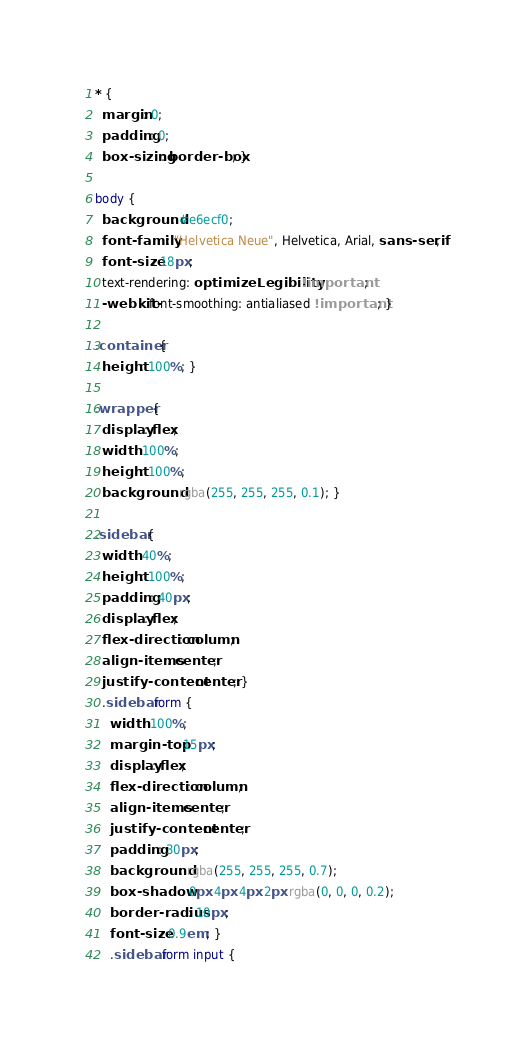Convert code to text. <code><loc_0><loc_0><loc_500><loc_500><_CSS_>* {
  margin: 0;
  padding: 0;
  box-sizing: border-box; }

body {
  background: #e6ecf0;
  font-family: "Helvetica Neue", Helvetica, Arial, sans-serif;
  font-size: 18px;
  text-rendering: optimizeLegibility !important;
  -webkit-font-smoothing: antialiased !important; }

.container {
  height: 100%; }

.wrapper {
  display: flex;
  width: 100%;
  height: 100%;
  background: rgba(255, 255, 255, 0.1); }

.sidebar {
  width: 40%;
  height: 100%;
  padding: 40px;
  display: flex;
  flex-direction: column;
  align-items: center;
  justify-content: center; }
  .sidebar form {
    width: 100%;
    margin-top: 15px;
    display: flex;
    flex-direction: column;
    align-items: center;
    justify-content: center;
    padding: 30px;
    background: rgba(255, 255, 255, 0.7);
    box-shadow: 0px 4px 4px 2px rgba(0, 0, 0, 0.2);
    border-radius: 10px;
    font-size: 0.9em; }
    .sidebar form input {</code> 